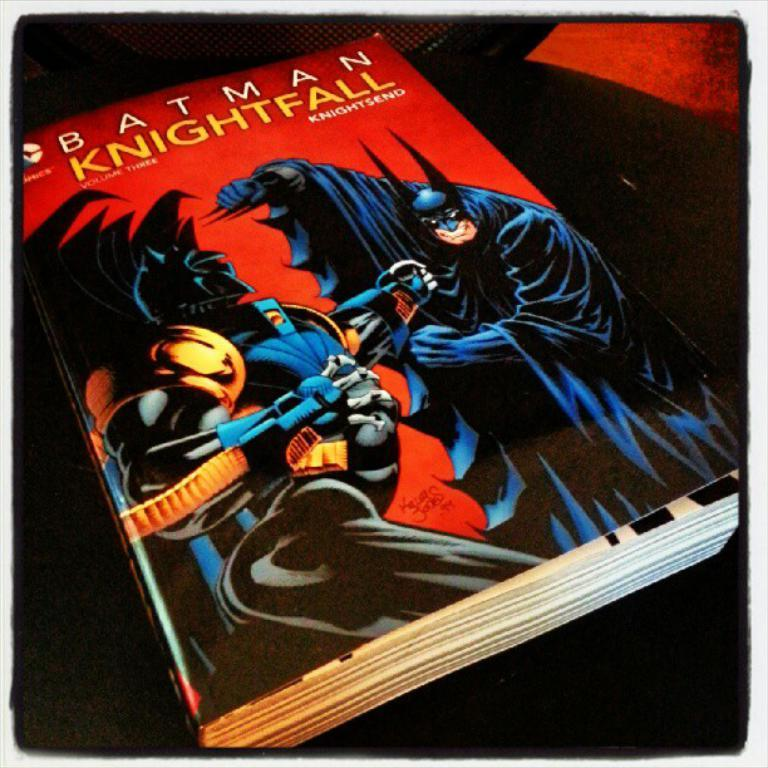<image>
Offer a succinct explanation of the picture presented. The batman book shown is volume three of the series. 